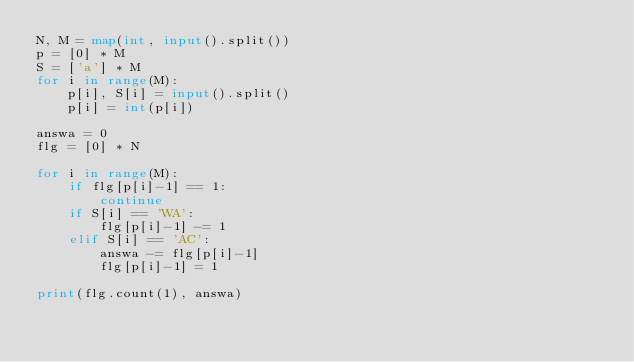<code> <loc_0><loc_0><loc_500><loc_500><_Python_>N, M = map(int, input().split())
p = [0] * M
S = ['a'] * M
for i in range(M):
    p[i], S[i] = input().split()
    p[i] = int(p[i])

answa = 0
flg = [0] * N

for i in range(M):
    if flg[p[i]-1] == 1:
        continue
    if S[i] == 'WA':
        flg[p[i]-1] -= 1
    elif S[i] == 'AC':
        answa -= flg[p[i]-1]
        flg[p[i]-1] = 1

print(flg.count(1), answa)</code> 